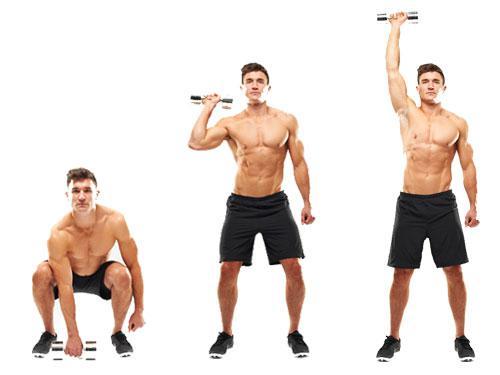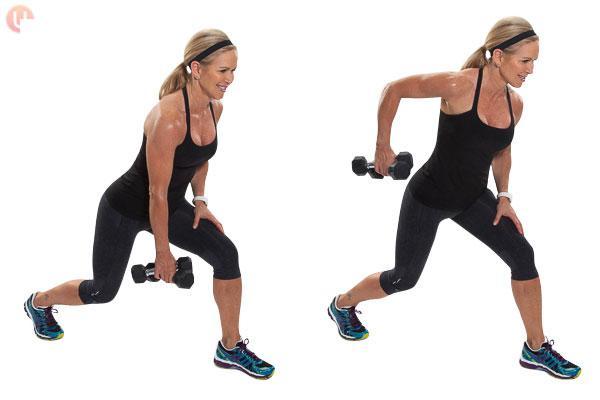The first image is the image on the left, the second image is the image on the right. Evaluate the accuracy of this statement regarding the images: "One image shows a man in a blue shirt doing exercises with weights, while the other image shows a shirtless man in blue shorts doing exercises with weights". Is it true? Answer yes or no. No. The first image is the image on the left, the second image is the image on the right. Analyze the images presented: Is the assertion "An image shows a workout sequence featuring a man in blue shorts with dumbbells in each hand." valid? Answer yes or no. No. 